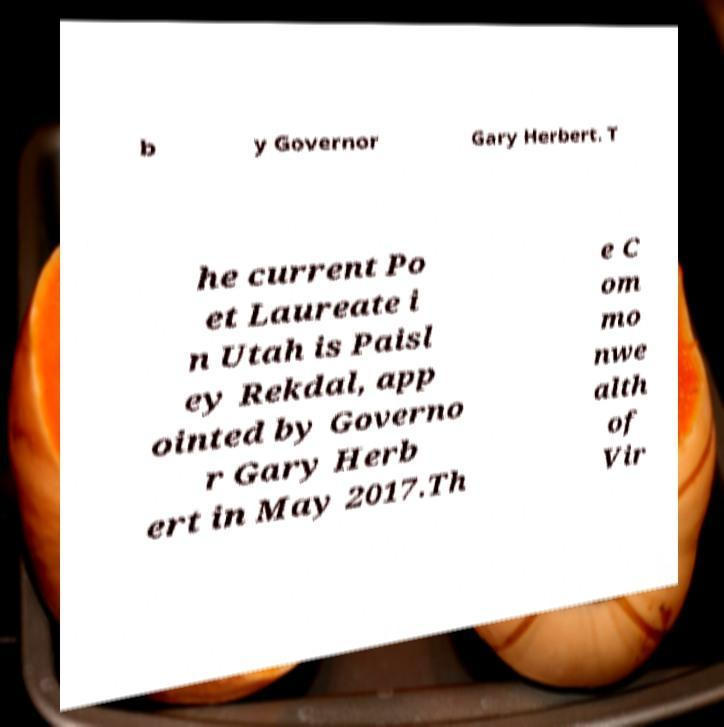Please identify and transcribe the text found in this image. b y Governor Gary Herbert. T he current Po et Laureate i n Utah is Paisl ey Rekdal, app ointed by Governo r Gary Herb ert in May 2017.Th e C om mo nwe alth of Vir 